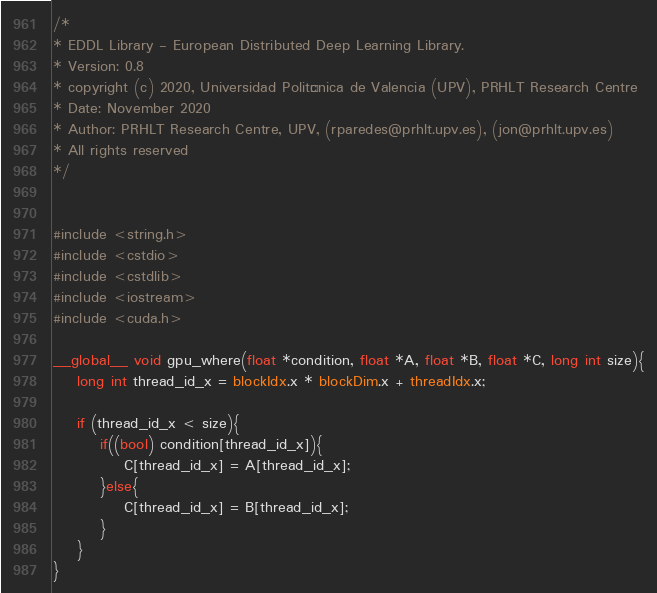<code> <loc_0><loc_0><loc_500><loc_500><_Cuda_>/*
* EDDL Library - European Distributed Deep Learning Library.
* Version: 0.8
* copyright (c) 2020, Universidad Politécnica de Valencia (UPV), PRHLT Research Centre
* Date: November 2020
* Author: PRHLT Research Centre, UPV, (rparedes@prhlt.upv.es), (jon@prhlt.upv.es)
* All rights reserved
*/


#include <string.h>
#include <cstdio>
#include <cstdlib>
#include <iostream>
#include <cuda.h>

__global__ void gpu_where(float *condition, float *A, float *B, float *C, long int size){
    long int thread_id_x = blockIdx.x * blockDim.x + threadIdx.x;

    if (thread_id_x < size){
        if((bool) condition[thread_id_x]){
            C[thread_id_x] = A[thread_id_x];
        }else{
            C[thread_id_x] = B[thread_id_x];
        }
    }
}
</code> 